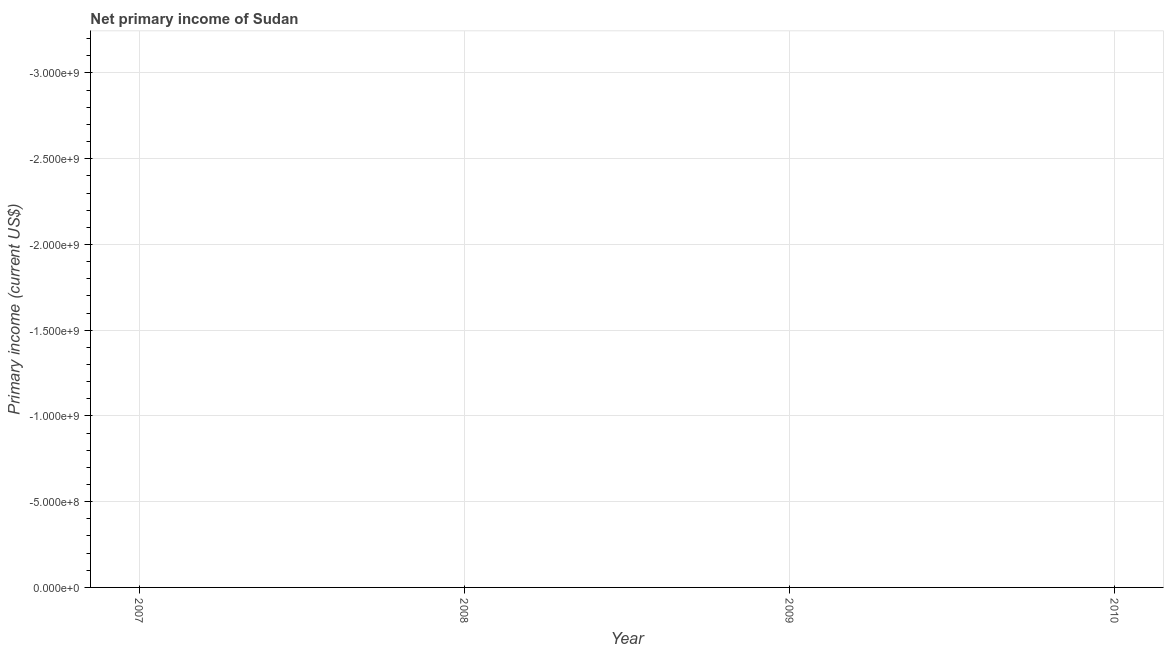What is the amount of primary income in 2008?
Provide a short and direct response. 0. What is the median amount of primary income?
Your answer should be very brief. 0. In how many years, is the amount of primary income greater than the average amount of primary income taken over all years?
Give a very brief answer. 0. Does the graph contain any zero values?
Keep it short and to the point. Yes. What is the title of the graph?
Your answer should be compact. Net primary income of Sudan. What is the label or title of the X-axis?
Your response must be concise. Year. What is the label or title of the Y-axis?
Keep it short and to the point. Primary income (current US$). What is the Primary income (current US$) in 2007?
Ensure brevity in your answer.  0. 